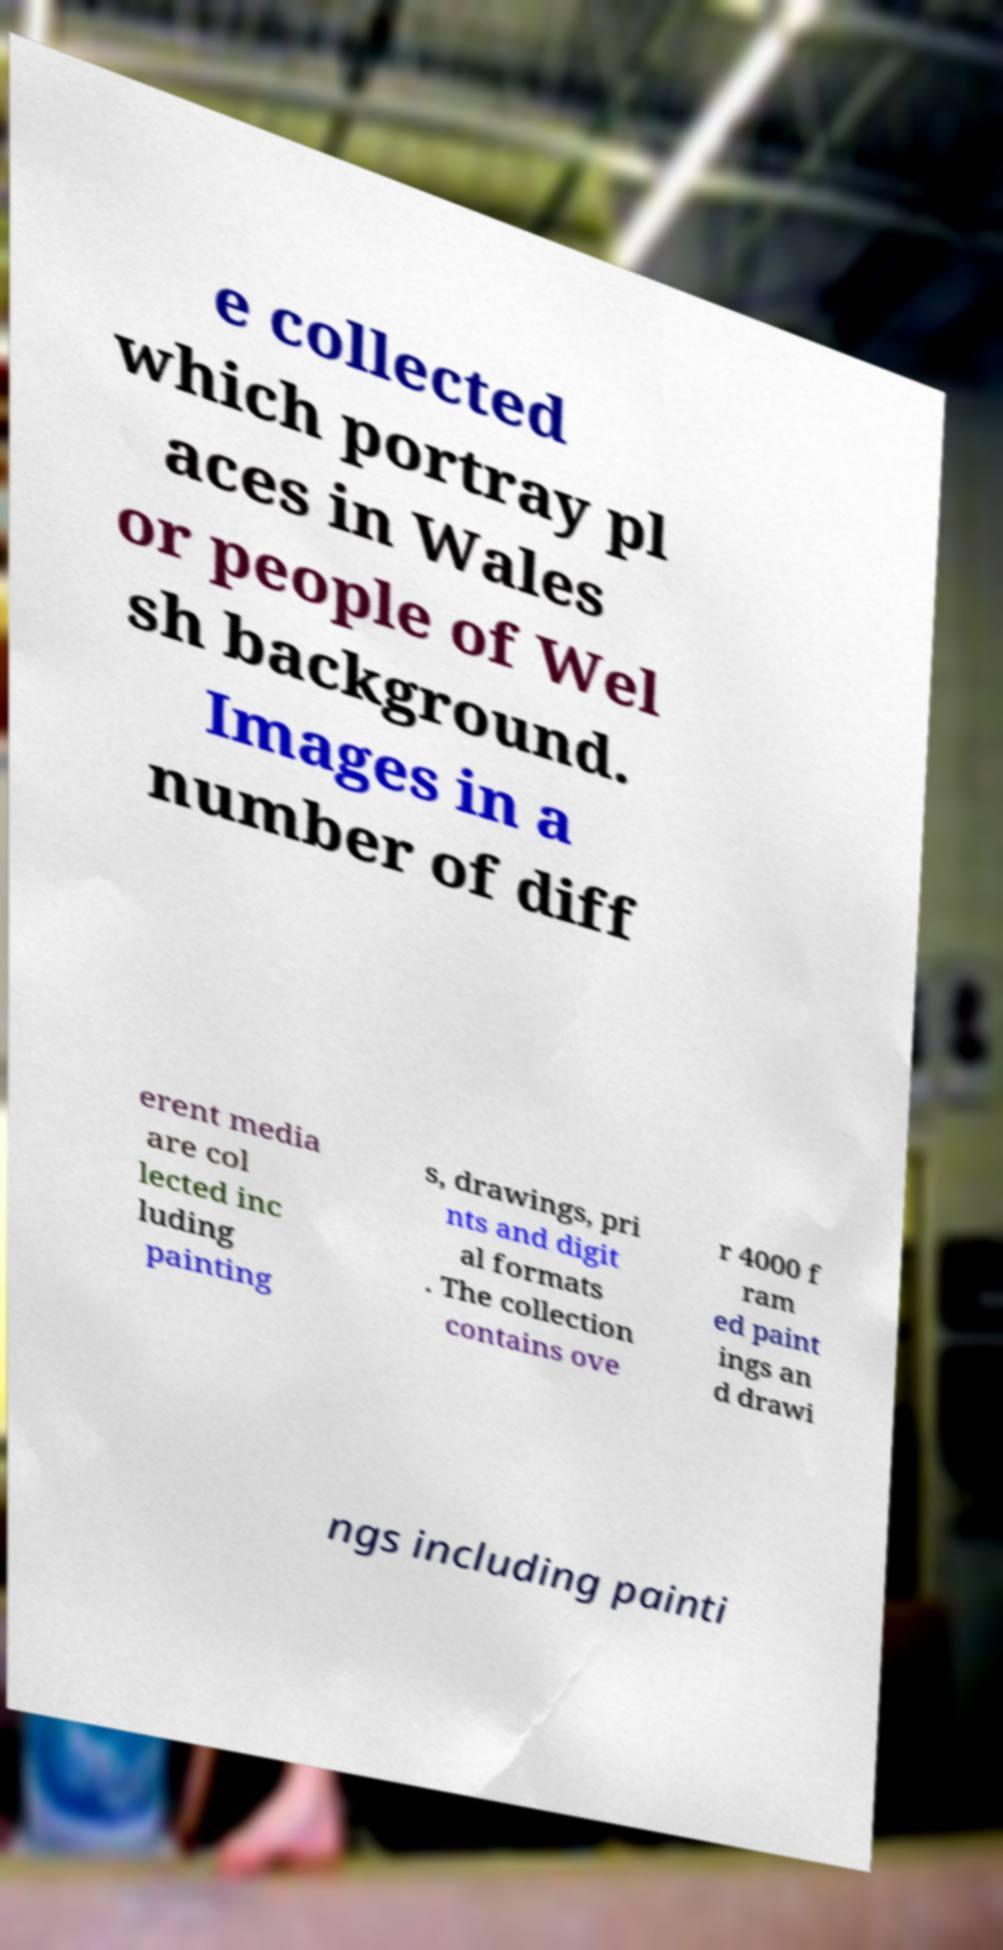Could you extract and type out the text from this image? e collected which portray pl aces in Wales or people of Wel sh background. Images in a number of diff erent media are col lected inc luding painting s, drawings, pri nts and digit al formats . The collection contains ove r 4000 f ram ed paint ings an d drawi ngs including painti 